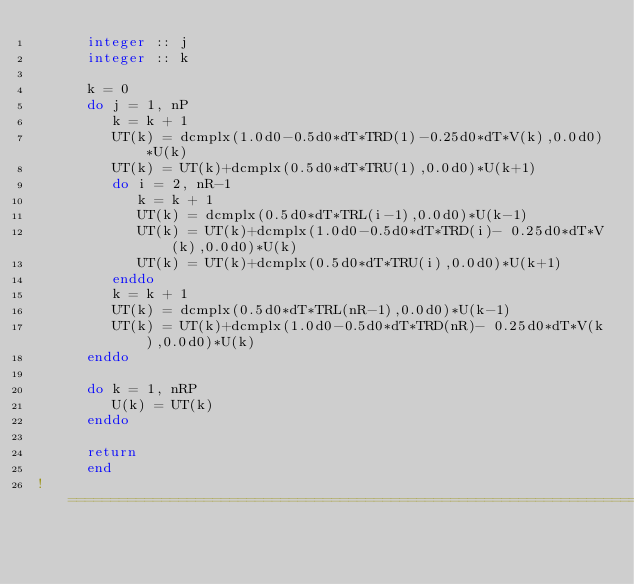Convert code to text. <code><loc_0><loc_0><loc_500><loc_500><_FORTRAN_>      integer :: j
      integer :: k

      k = 0
      do j = 1, nP
         k = k + 1
         UT(k) = dcmplx(1.0d0-0.5d0*dT*TRD(1)-0.25d0*dT*V(k),0.0d0)*U(k)
         UT(k) = UT(k)+dcmplx(0.5d0*dT*TRU(1),0.0d0)*U(k+1)
         do i = 2, nR-1
            k = k + 1
            UT(k) = dcmplx(0.5d0*dT*TRL(i-1),0.0d0)*U(k-1)
            UT(k) = UT(k)+dcmplx(1.0d0-0.5d0*dT*TRD(i)- 0.25d0*dT*V(k),0.0d0)*U(k)
            UT(k) = UT(k)+dcmplx(0.5d0*dT*TRU(i),0.0d0)*U(k+1)
         enddo
         k = k + 1
         UT(k) = dcmplx(0.5d0*dT*TRL(nR-1),0.0d0)*U(k-1)
         UT(k) = UT(k)+dcmplx(1.0d0-0.5d0*dT*TRD(nR)- 0.25d0*dT*V(k),0.0d0)*U(k)
      enddo

      do k = 1, nRP
         U(k) = UT(k)
      enddo

      return
      end
! =====================================================================
</code> 